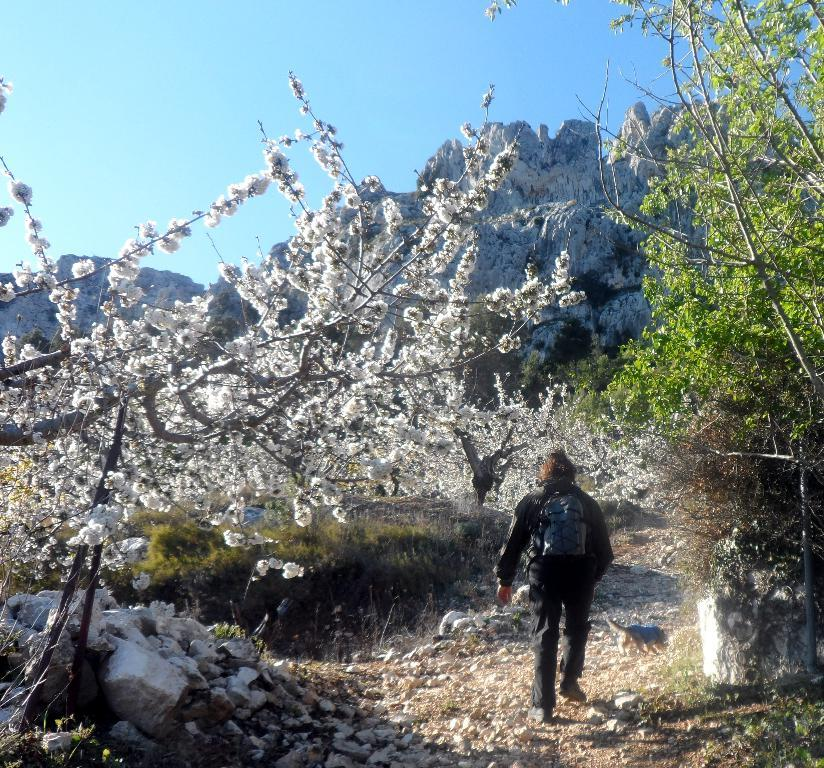What is located in the foreground of the image? There is a person and an animal on the road in the foreground of the image. What can be seen in the background of the image? Flowering plants, trees, mountains, and the sky are visible in the background of the image. What is the time of day when the image was likely taken? The image was likely taken during the day, as the sky is visible. What type of train system can be seen in the image? There is no train system present in the image. What is the weather like in the image, and is there any sleet visible? The weather cannot be determined from the image, and there is no sleet visible. 